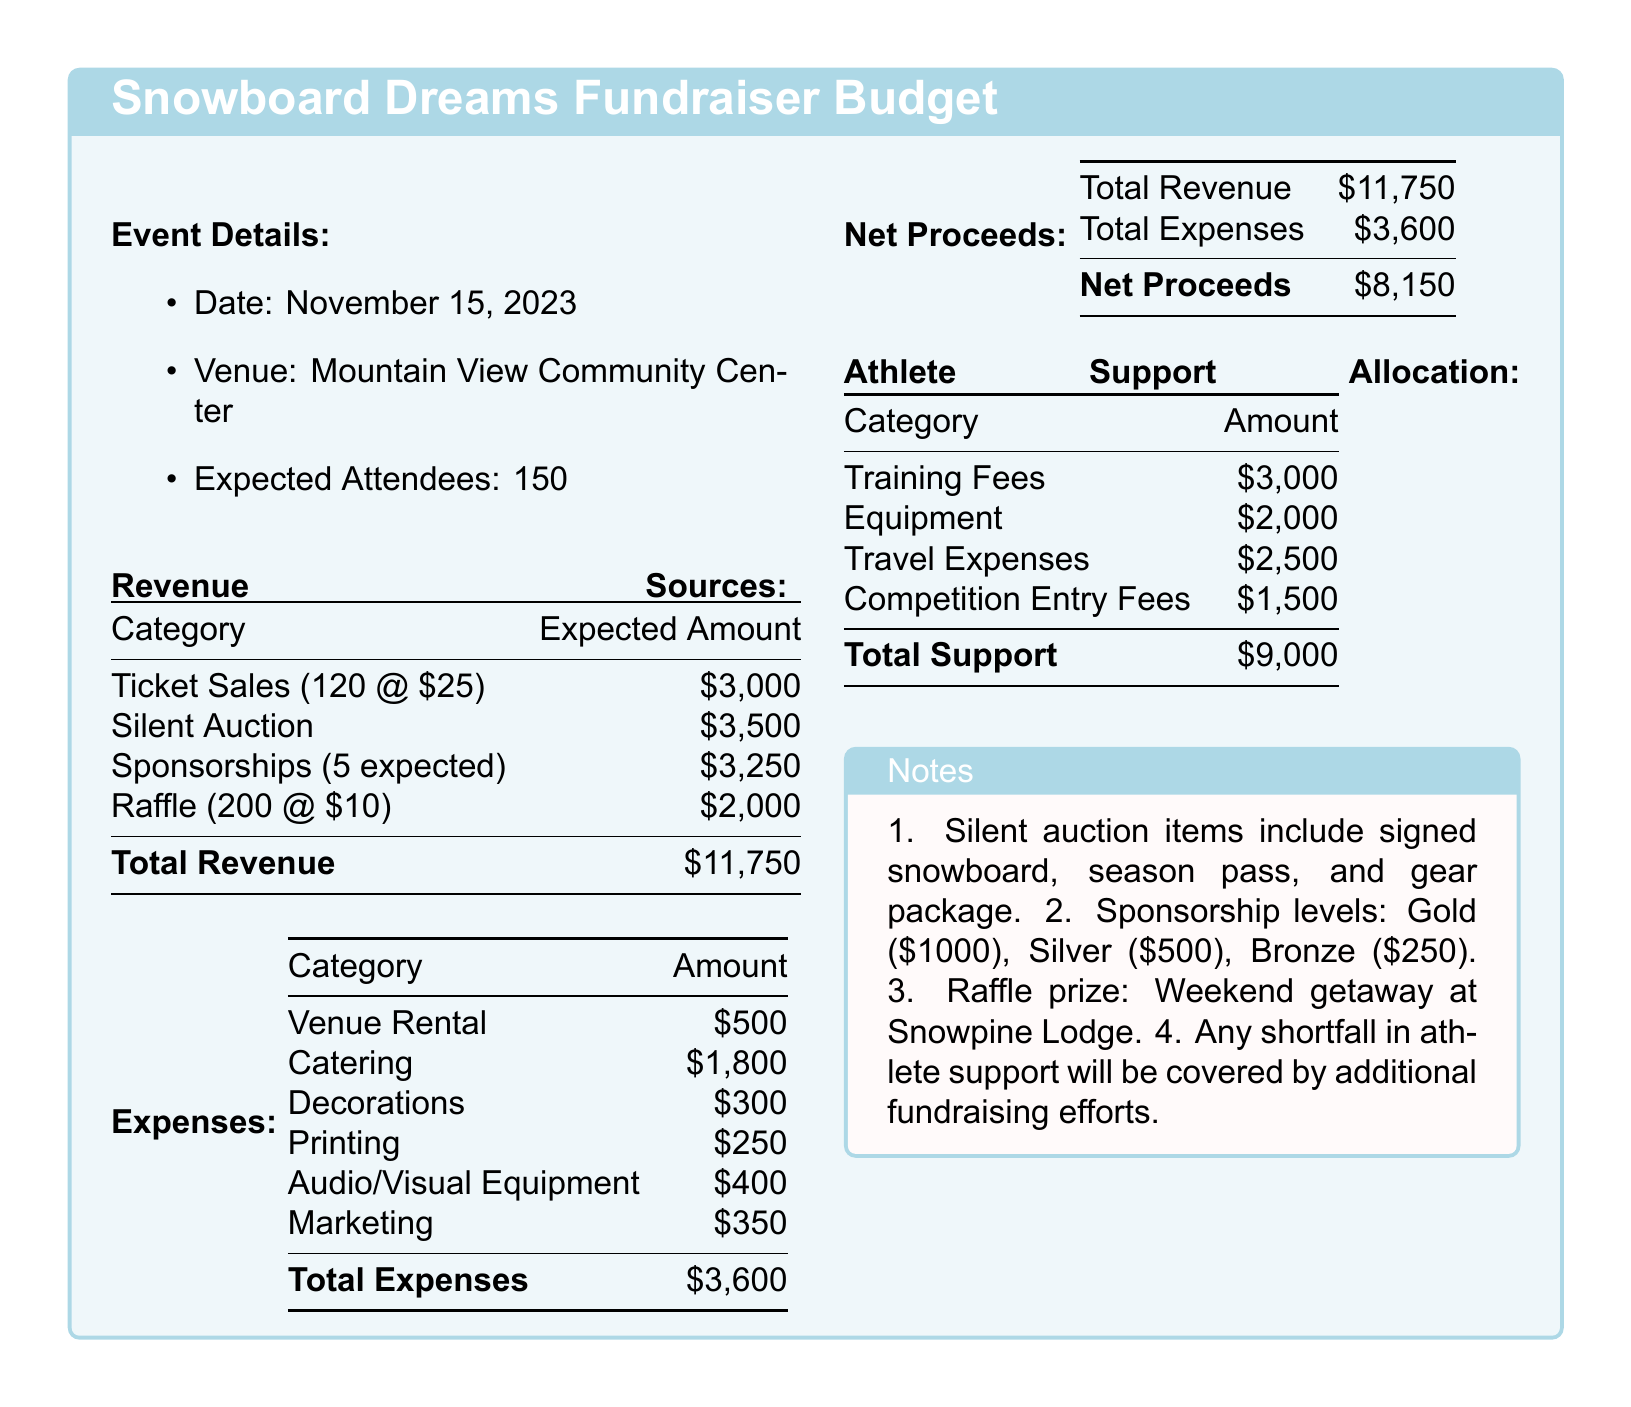what is the date of the event? The document states that the event will take place on November 15, 2023.
Answer: November 15, 2023 how many expected attendees are there? The document mentions that there are expected to be 150 attendees at the fundraiser.
Answer: 150 what is the expected amount from ticket sales? The expected amount from ticket sales is calculated as 120 tickets at $25 each, resulting in $3,000.
Answer: $3,000 what are the total expenses for the event? The total expenses are listed as the sum of all expense categories in the document, amounting to $3,600.
Answer: $3,600 what is the net proceeds from the fundraiser? The net proceeds are calculated from total revenue minus total expenses, which is $11,750 - $3,600.
Answer: $8,150 how much will be allocated for travel expenses? The athlete support allocation shows that $2,500 will be used for travel expenses.
Answer: $2,500 how many sponsorships are expected? The document states that there are 5 expected sponsorships for the event.
Answer: 5 what is the value of the raffle prize? The raffle prize mentioned in the notes is a weekend getaway at Snowpine Lodge.
Answer: Weekend getaway at Snowpine Lodge what is the budget for equipment? The document specifies that the budget for equipment is $2,000.
Answer: $2,000 what types of items will be in the silent auction? The document lists items for the silent auction, including a signed snowboard, season pass, and gear package.
Answer: Signed snowboard, season pass, gear package 